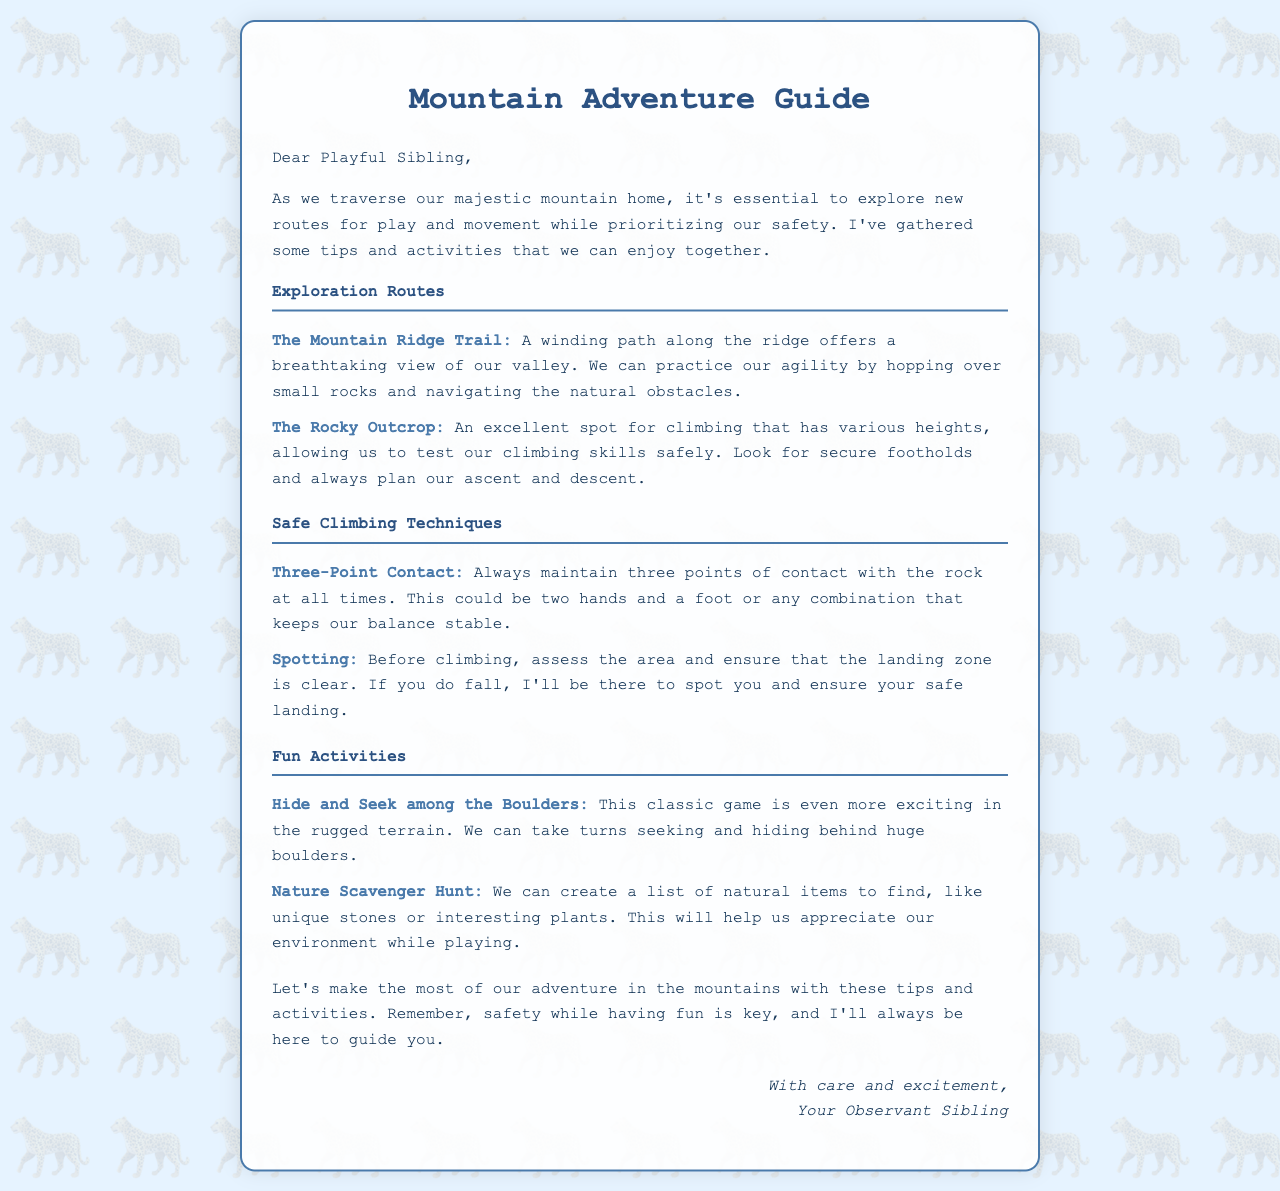What is the title of the letter? The title of the letter is prominently displayed at the top of the document.
Answer: Mountain Adventure Guide Who is the letter addressed to? The letter is personally directed towards a specific individual, referred to in the salutation.
Answer: Playful Sibling What is one of the activities suggested for fun? The document lists several fun activities, and one is highlighted under the Fun Activities section.
Answer: Hide and Seek among the Boulders What climbing technique emphasizes keeping three points of contact? Specific techniques are outlined for safe climbing practices, one of which is mentioned.
Answer: Three-Point Contact How many exploration routes are mentioned? The letter lists two distinct places to explore for play and movement.
Answer: Two What type of game can be played with a nature scavenger hunt? A specific activity that can help appreciate the environment is described in the letter.
Answer: A list of natural items to find What is a key aspect of safety mentioned for climbing? The letter discusses safety practices that are essential when climbing, particularly regarding falls.
Answer: Spotting Which route offers breathtaking views? The letter describes an exploration route that provides beautiful scenery to enjoy while moving.
Answer: The Mountain Ridge Trail 